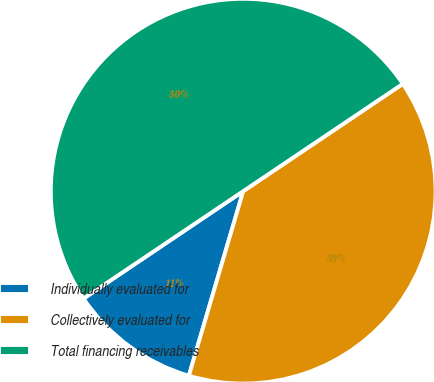Convert chart. <chart><loc_0><loc_0><loc_500><loc_500><pie_chart><fcel>Individually evaluated for<fcel>Collectively evaluated for<fcel>Total financing receivables<nl><fcel>11.02%<fcel>38.98%<fcel>50.0%<nl></chart> 